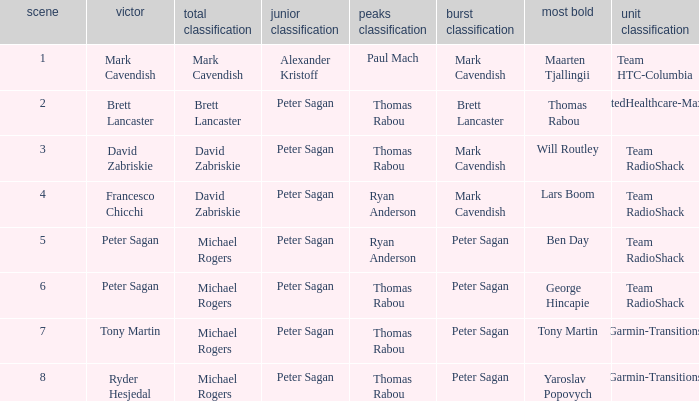When Yaroslav Popovych won most corageous, who won the mountains classification? Thomas Rabou. 